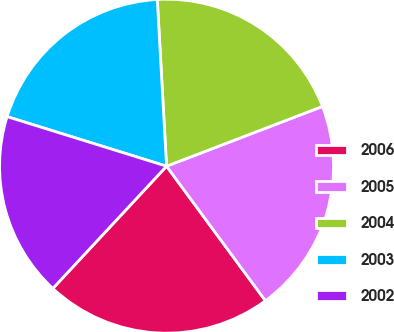<chart> <loc_0><loc_0><loc_500><loc_500><pie_chart><fcel>2006<fcel>2005<fcel>2004<fcel>2003<fcel>2002<nl><fcel>22.01%<fcel>20.74%<fcel>20.06%<fcel>19.32%<fcel>17.87%<nl></chart> 